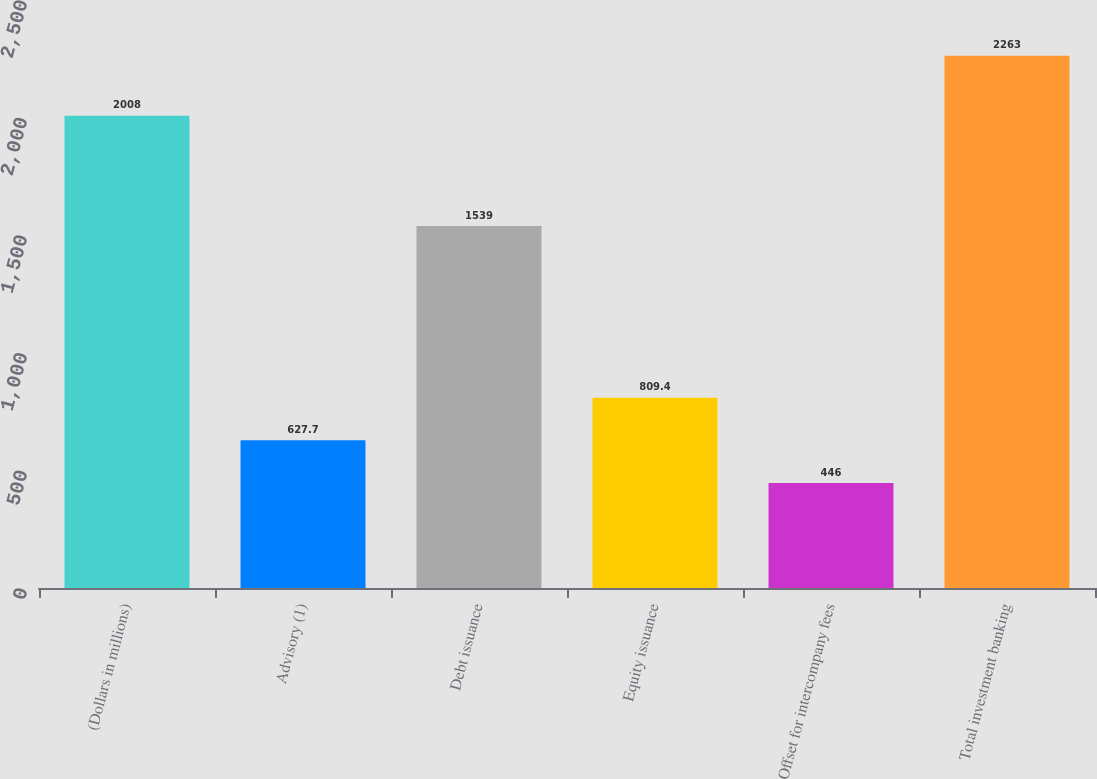Convert chart. <chart><loc_0><loc_0><loc_500><loc_500><bar_chart><fcel>(Dollars in millions)<fcel>Advisory (1)<fcel>Debt issuance<fcel>Equity issuance<fcel>Offset for intercompany fees<fcel>Total investment banking<nl><fcel>2008<fcel>627.7<fcel>1539<fcel>809.4<fcel>446<fcel>2263<nl></chart> 